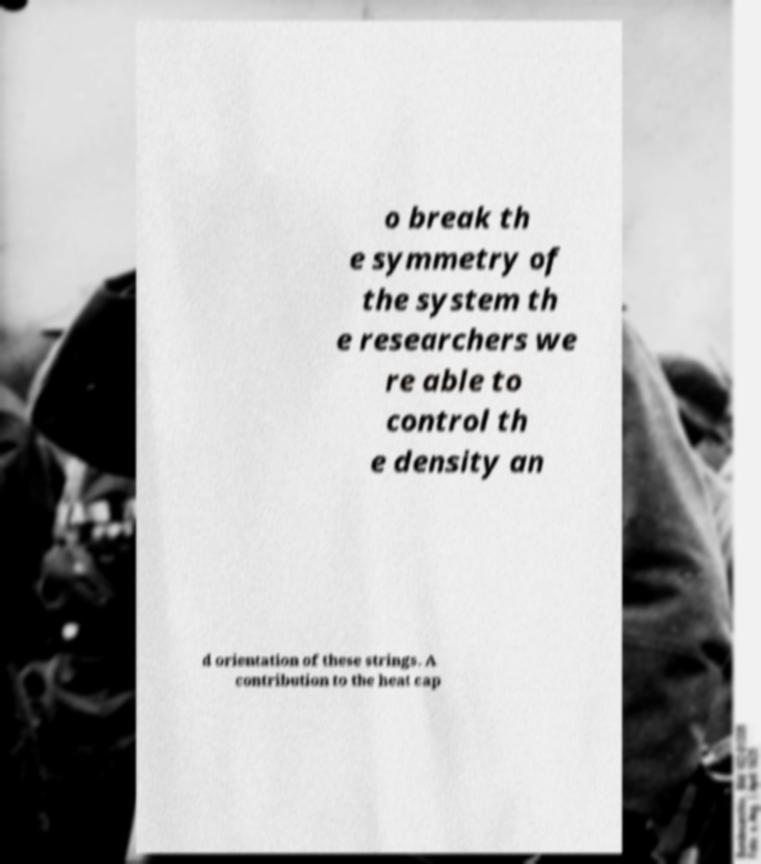For documentation purposes, I need the text within this image transcribed. Could you provide that? o break th e symmetry of the system th e researchers we re able to control th e density an d orientation of these strings. A contribution to the heat cap 